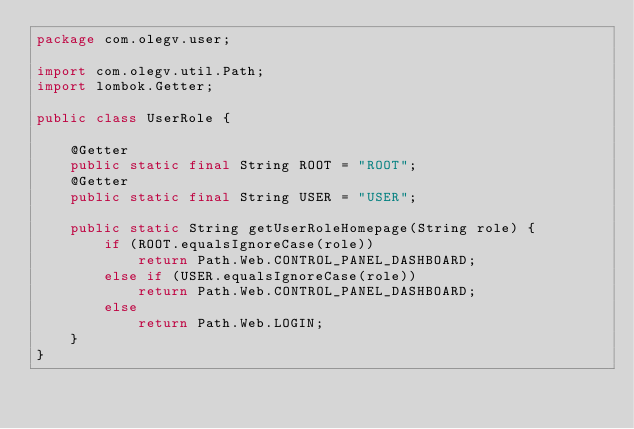Convert code to text. <code><loc_0><loc_0><loc_500><loc_500><_Java_>package com.olegv.user;

import com.olegv.util.Path;
import lombok.Getter;

public class UserRole {
    
    @Getter
    public static final String ROOT = "ROOT";
    @Getter
    public static final String USER = "USER";
    
    public static String getUserRoleHomepage(String role) {
        if (ROOT.equalsIgnoreCase(role))
            return Path.Web.CONTROL_PANEL_DASHBOARD;
        else if (USER.equalsIgnoreCase(role))
            return Path.Web.CONTROL_PANEL_DASHBOARD;
        else
            return Path.Web.LOGIN;
    }
}
</code> 